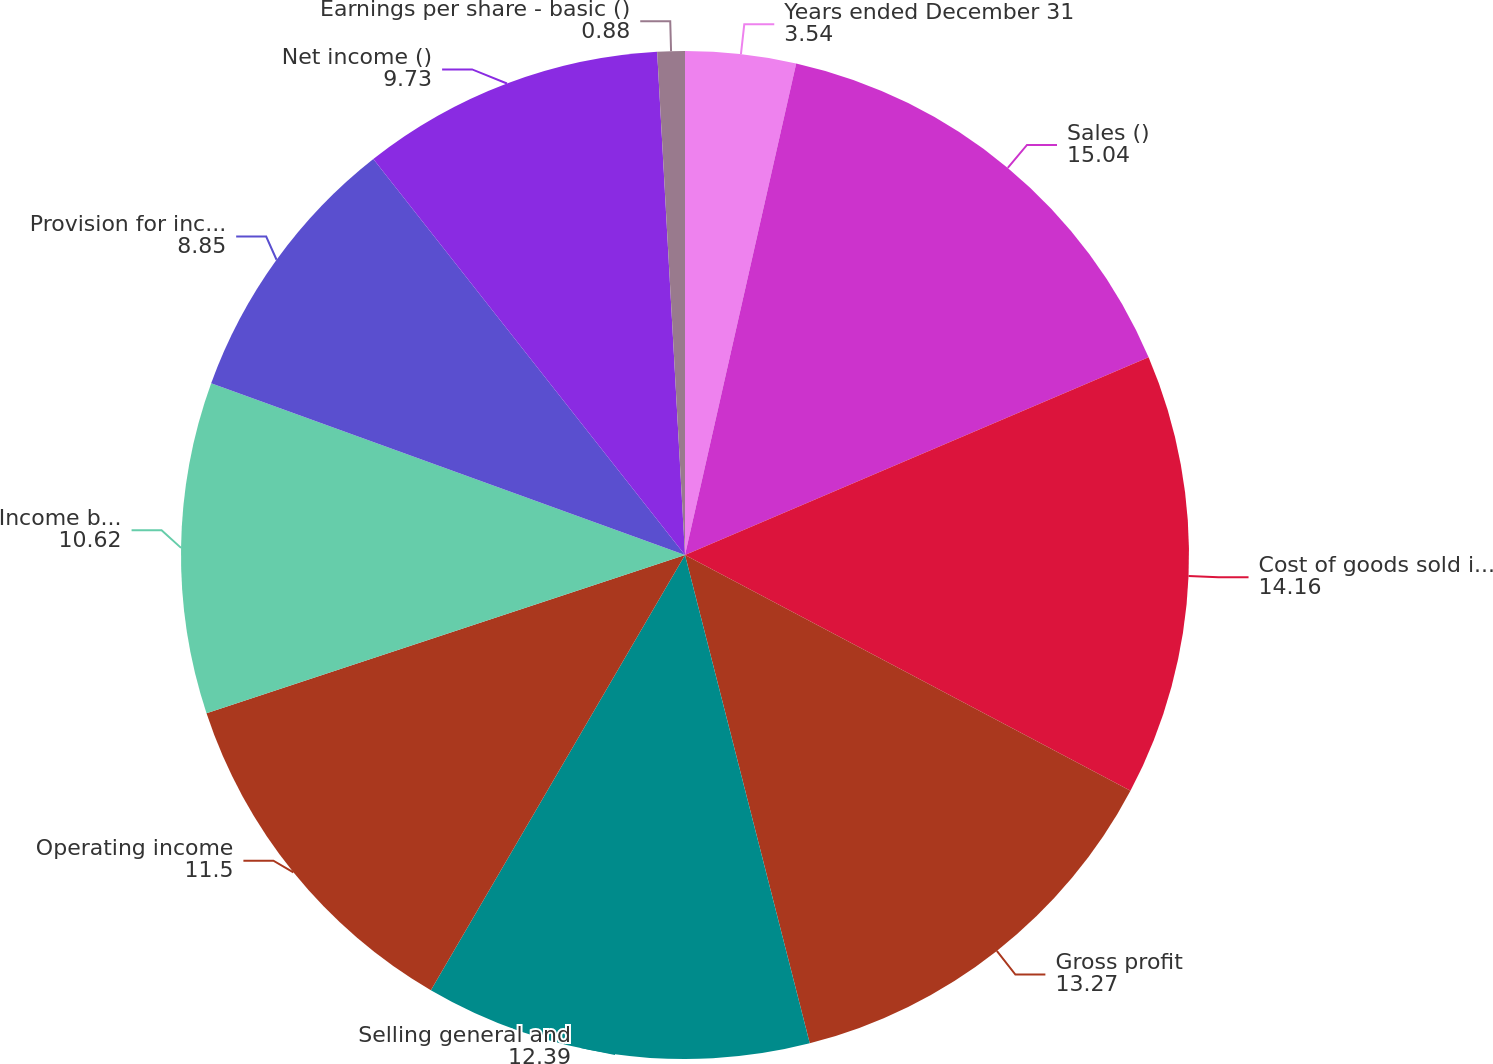Convert chart. <chart><loc_0><loc_0><loc_500><loc_500><pie_chart><fcel>Years ended December 31<fcel>Sales ()<fcel>Cost of goods sold including<fcel>Gross profit<fcel>Selling general and<fcel>Operating income<fcel>Income before income taxes<fcel>Provision for income taxes<fcel>Net income ()<fcel>Earnings per share - basic ()<nl><fcel>3.54%<fcel>15.04%<fcel>14.16%<fcel>13.27%<fcel>12.39%<fcel>11.5%<fcel>10.62%<fcel>8.85%<fcel>9.73%<fcel>0.88%<nl></chart> 